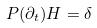<formula> <loc_0><loc_0><loc_500><loc_500>P ( \partial _ { t } ) H = \delta</formula> 